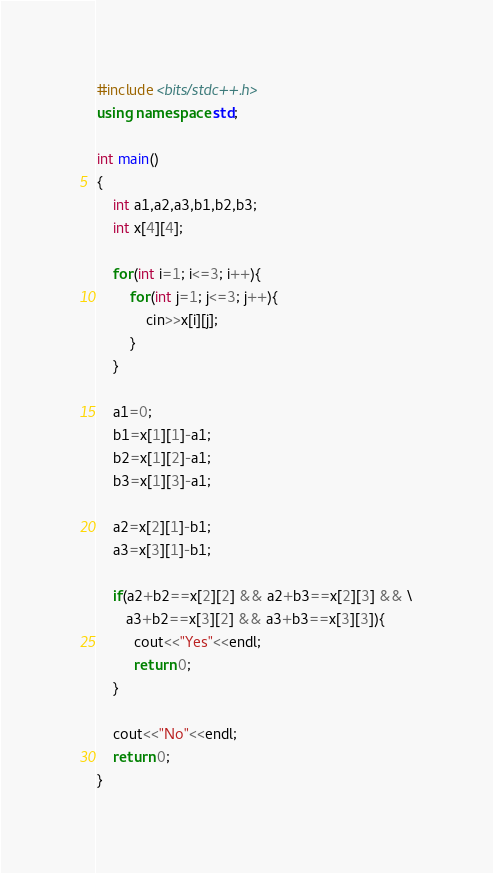Convert code to text. <code><loc_0><loc_0><loc_500><loc_500><_C++_>#include <bits/stdc++.h>
using namespace std;

int main()
{
	int a1,a2,a3,b1,b2,b3;
	int x[4][4];
	
	for(int i=1; i<=3; i++){
		for(int j=1; j<=3; j++){
			cin>>x[i][j];
		}
	}
	
	a1=0;
	b1=x[1][1]-a1;
	b2=x[1][2]-a1;
	b3=x[1][3]-a1;
	
	a2=x[2][1]-b1;
	a3=x[3][1]-b1;
	
	if(a2+b2==x[2][2] && a2+b3==x[2][3] && \
	   a3+b2==x[3][2] && a3+b3==x[3][3]){
		 cout<<"Yes"<<endl;
		 return 0;
	}
	
	cout<<"No"<<endl;
	return 0;
}</code> 